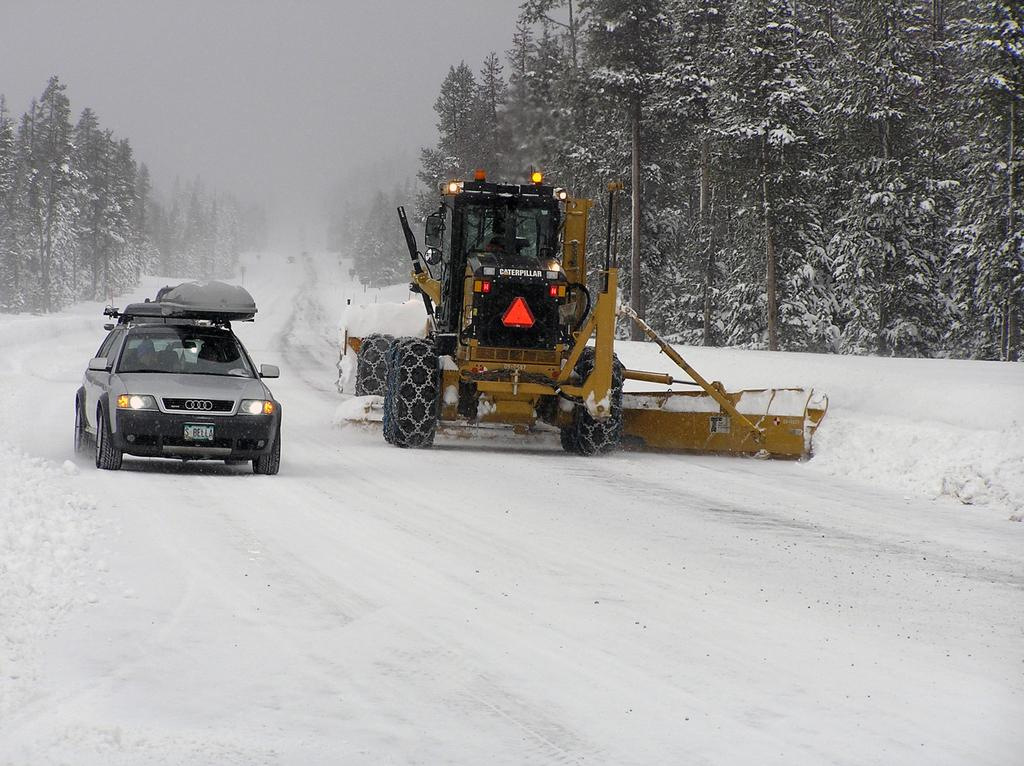What is the main feature of the image? There is a road in the image. What is the condition of the road? There is snow on the road. What type of vehicle can be seen in the image? There is a vehicle in the image. What other machinery is present in the image? There is an excavator in the image. What can be seen on the sides of the road? Trees are present on the sides of the road. How do the trees appear in the image? The trees are covered with snow. What color of paint is being used to decorate the hands of the lumberjacks in the image? There are no lumberjacks or hands present in the image, and therefore no paint can be observed. 